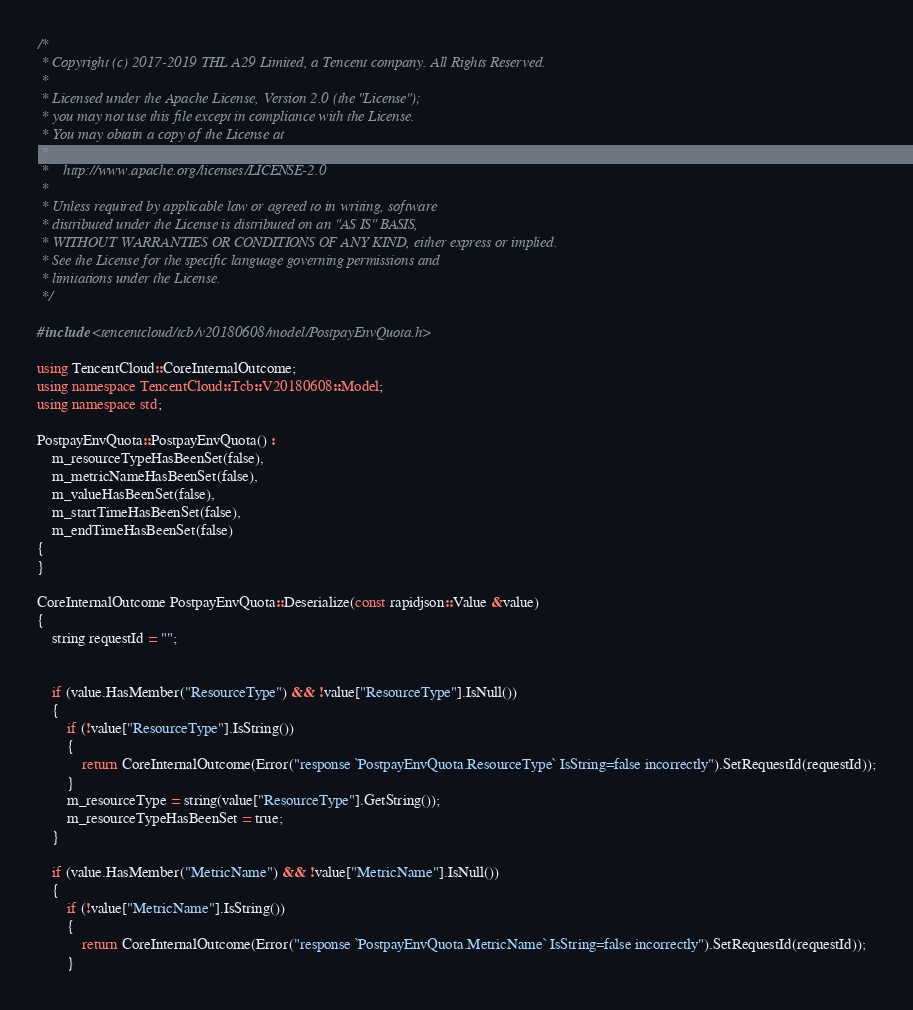Convert code to text. <code><loc_0><loc_0><loc_500><loc_500><_C++_>/*
 * Copyright (c) 2017-2019 THL A29 Limited, a Tencent company. All Rights Reserved.
 *
 * Licensed under the Apache License, Version 2.0 (the "License");
 * you may not use this file except in compliance with the License.
 * You may obtain a copy of the License at
 *
 *    http://www.apache.org/licenses/LICENSE-2.0
 *
 * Unless required by applicable law or agreed to in writing, software
 * distributed under the License is distributed on an "AS IS" BASIS,
 * WITHOUT WARRANTIES OR CONDITIONS OF ANY KIND, either express or implied.
 * See the License for the specific language governing permissions and
 * limitations under the License.
 */

#include <tencentcloud/tcb/v20180608/model/PostpayEnvQuota.h>

using TencentCloud::CoreInternalOutcome;
using namespace TencentCloud::Tcb::V20180608::Model;
using namespace std;

PostpayEnvQuota::PostpayEnvQuota() :
    m_resourceTypeHasBeenSet(false),
    m_metricNameHasBeenSet(false),
    m_valueHasBeenSet(false),
    m_startTimeHasBeenSet(false),
    m_endTimeHasBeenSet(false)
{
}

CoreInternalOutcome PostpayEnvQuota::Deserialize(const rapidjson::Value &value)
{
    string requestId = "";


    if (value.HasMember("ResourceType") && !value["ResourceType"].IsNull())
    {
        if (!value["ResourceType"].IsString())
        {
            return CoreInternalOutcome(Error("response `PostpayEnvQuota.ResourceType` IsString=false incorrectly").SetRequestId(requestId));
        }
        m_resourceType = string(value["ResourceType"].GetString());
        m_resourceTypeHasBeenSet = true;
    }

    if (value.HasMember("MetricName") && !value["MetricName"].IsNull())
    {
        if (!value["MetricName"].IsString())
        {
            return CoreInternalOutcome(Error("response `PostpayEnvQuota.MetricName` IsString=false incorrectly").SetRequestId(requestId));
        }</code> 